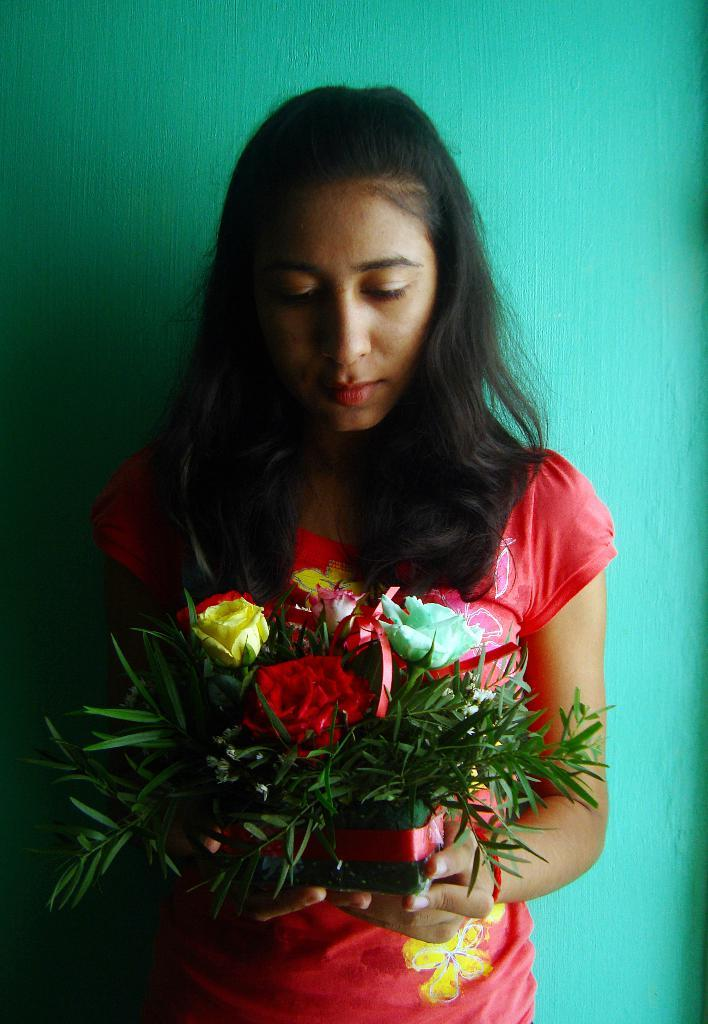Who is the main subject in the image? There is a woman in the image. Where is the woman positioned in the image? The woman is standing in the middle of the image. What is the woman holding in the image? The woman is holding flowers. What can be seen in the background of the image? There is a wall in the background of the image. What type of humor can be heard coming from the woman in the image? There is no indication of humor or any sounds in the image, so it's not possible to determine what, if any humor might be heard. 